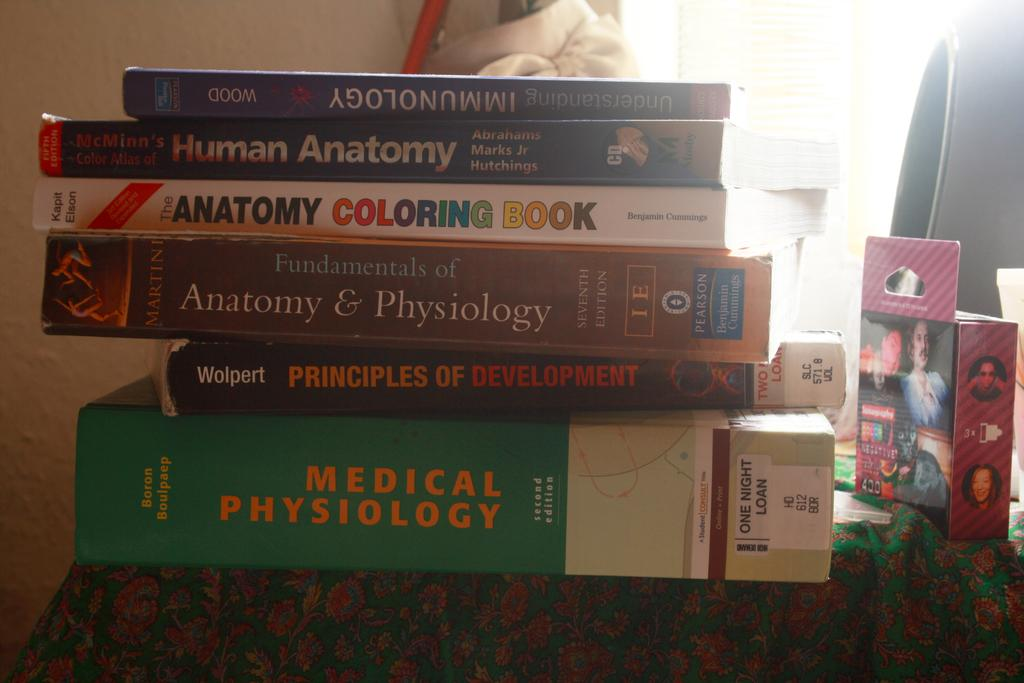<image>
Describe the image concisely. A book about medical physiology is on the bottom of a stack of books. 